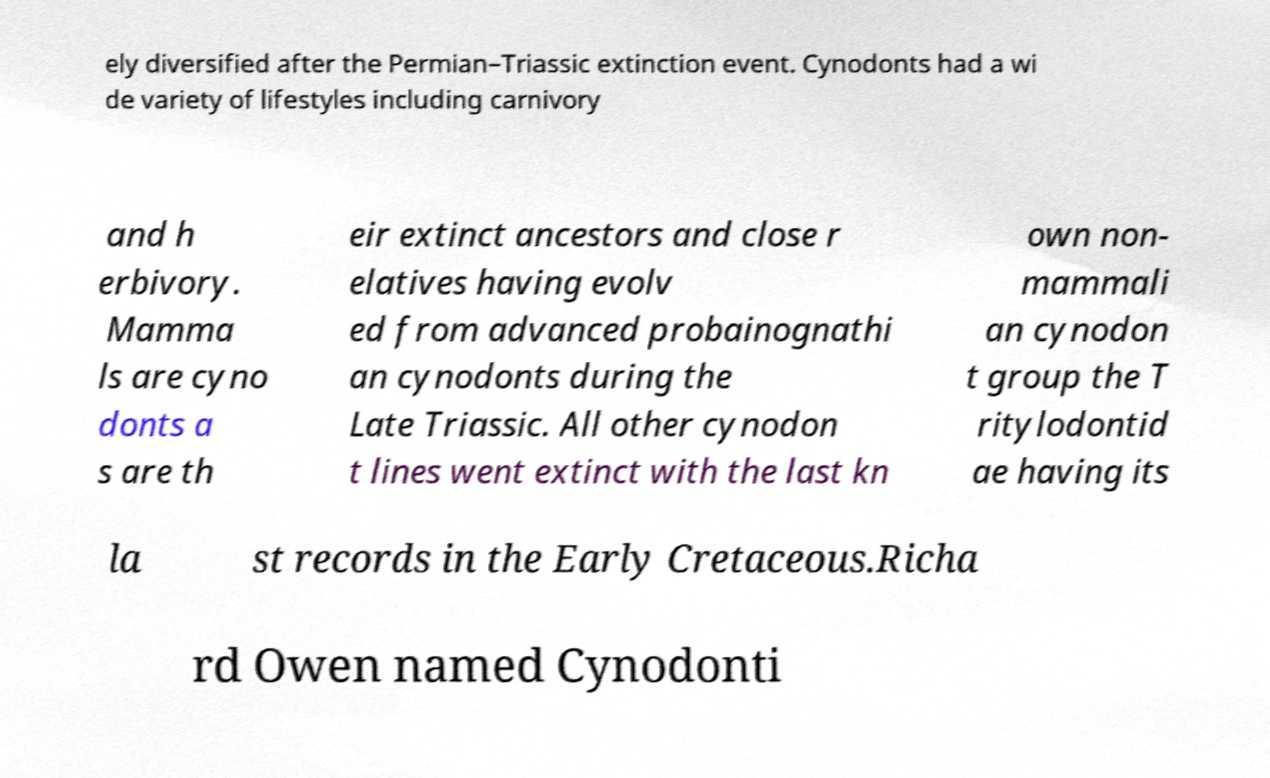Could you assist in decoding the text presented in this image and type it out clearly? ely diversified after the Permian–Triassic extinction event. Cynodonts had a wi de variety of lifestyles including carnivory and h erbivory. Mamma ls are cyno donts a s are th eir extinct ancestors and close r elatives having evolv ed from advanced probainognathi an cynodonts during the Late Triassic. All other cynodon t lines went extinct with the last kn own non- mammali an cynodon t group the T ritylodontid ae having its la st records in the Early Cretaceous.Richa rd Owen named Cynodonti 